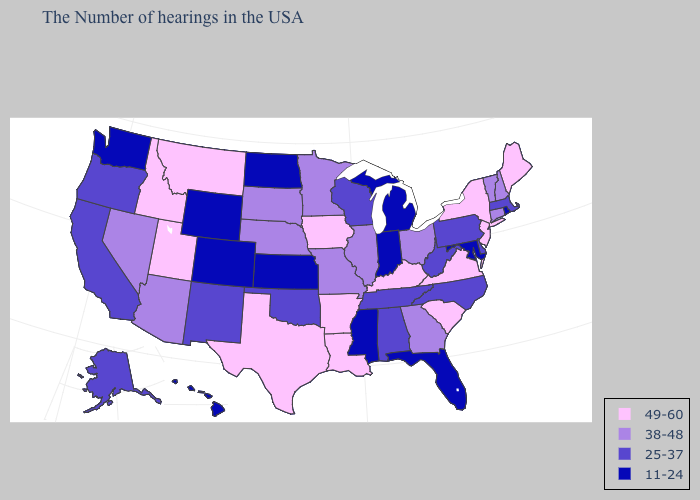Name the states that have a value in the range 25-37?
Give a very brief answer. Massachusetts, Delaware, Pennsylvania, North Carolina, West Virginia, Alabama, Tennessee, Wisconsin, Oklahoma, New Mexico, California, Oregon, Alaska. What is the lowest value in the USA?
Be succinct. 11-24. Name the states that have a value in the range 25-37?
Keep it brief. Massachusetts, Delaware, Pennsylvania, North Carolina, West Virginia, Alabama, Tennessee, Wisconsin, Oklahoma, New Mexico, California, Oregon, Alaska. What is the highest value in the Northeast ?
Quick response, please. 49-60. What is the lowest value in states that border Texas?
Write a very short answer. 25-37. Name the states that have a value in the range 25-37?
Be succinct. Massachusetts, Delaware, Pennsylvania, North Carolina, West Virginia, Alabama, Tennessee, Wisconsin, Oklahoma, New Mexico, California, Oregon, Alaska. Name the states that have a value in the range 38-48?
Quick response, please. New Hampshire, Vermont, Connecticut, Ohio, Georgia, Illinois, Missouri, Minnesota, Nebraska, South Dakota, Arizona, Nevada. What is the value of Florida?
Give a very brief answer. 11-24. Which states have the lowest value in the MidWest?
Write a very short answer. Michigan, Indiana, Kansas, North Dakota. Which states hav the highest value in the MidWest?
Keep it brief. Iowa. What is the value of Alaska?
Quick response, please. 25-37. What is the lowest value in the USA?
Keep it brief. 11-24. Which states have the highest value in the USA?
Write a very short answer. Maine, New York, New Jersey, Virginia, South Carolina, Kentucky, Louisiana, Arkansas, Iowa, Texas, Utah, Montana, Idaho. What is the value of Vermont?
Keep it brief. 38-48. Does Idaho have the highest value in the USA?
Write a very short answer. Yes. 